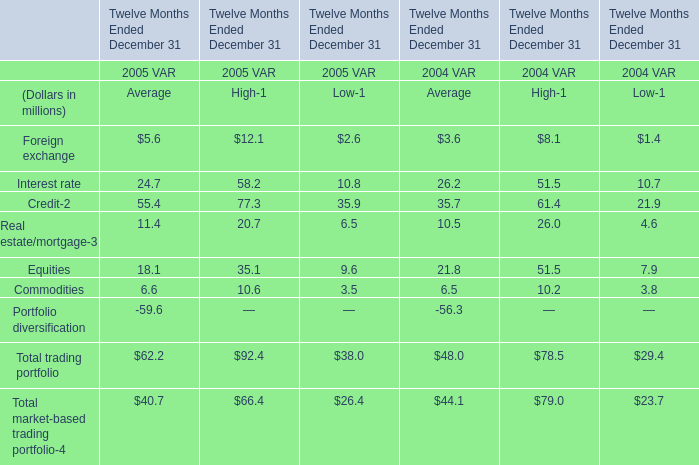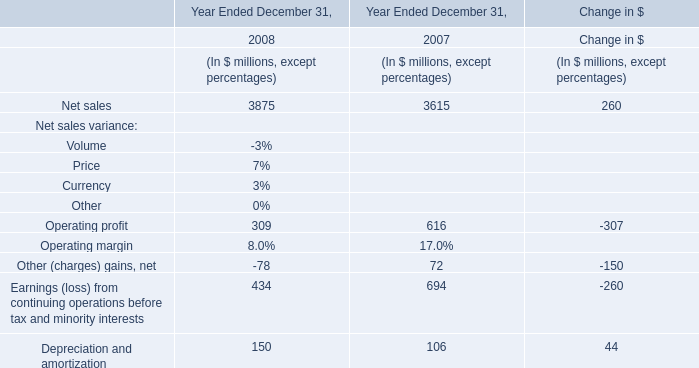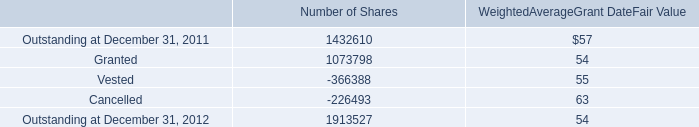What's the total amount of Foreign exchange, Interest rate, Credit and Equities in 2005? (in million) 
Computations: (((5.6 + 24.7) + 55.4) + 18.1)
Answer: 103.8. 